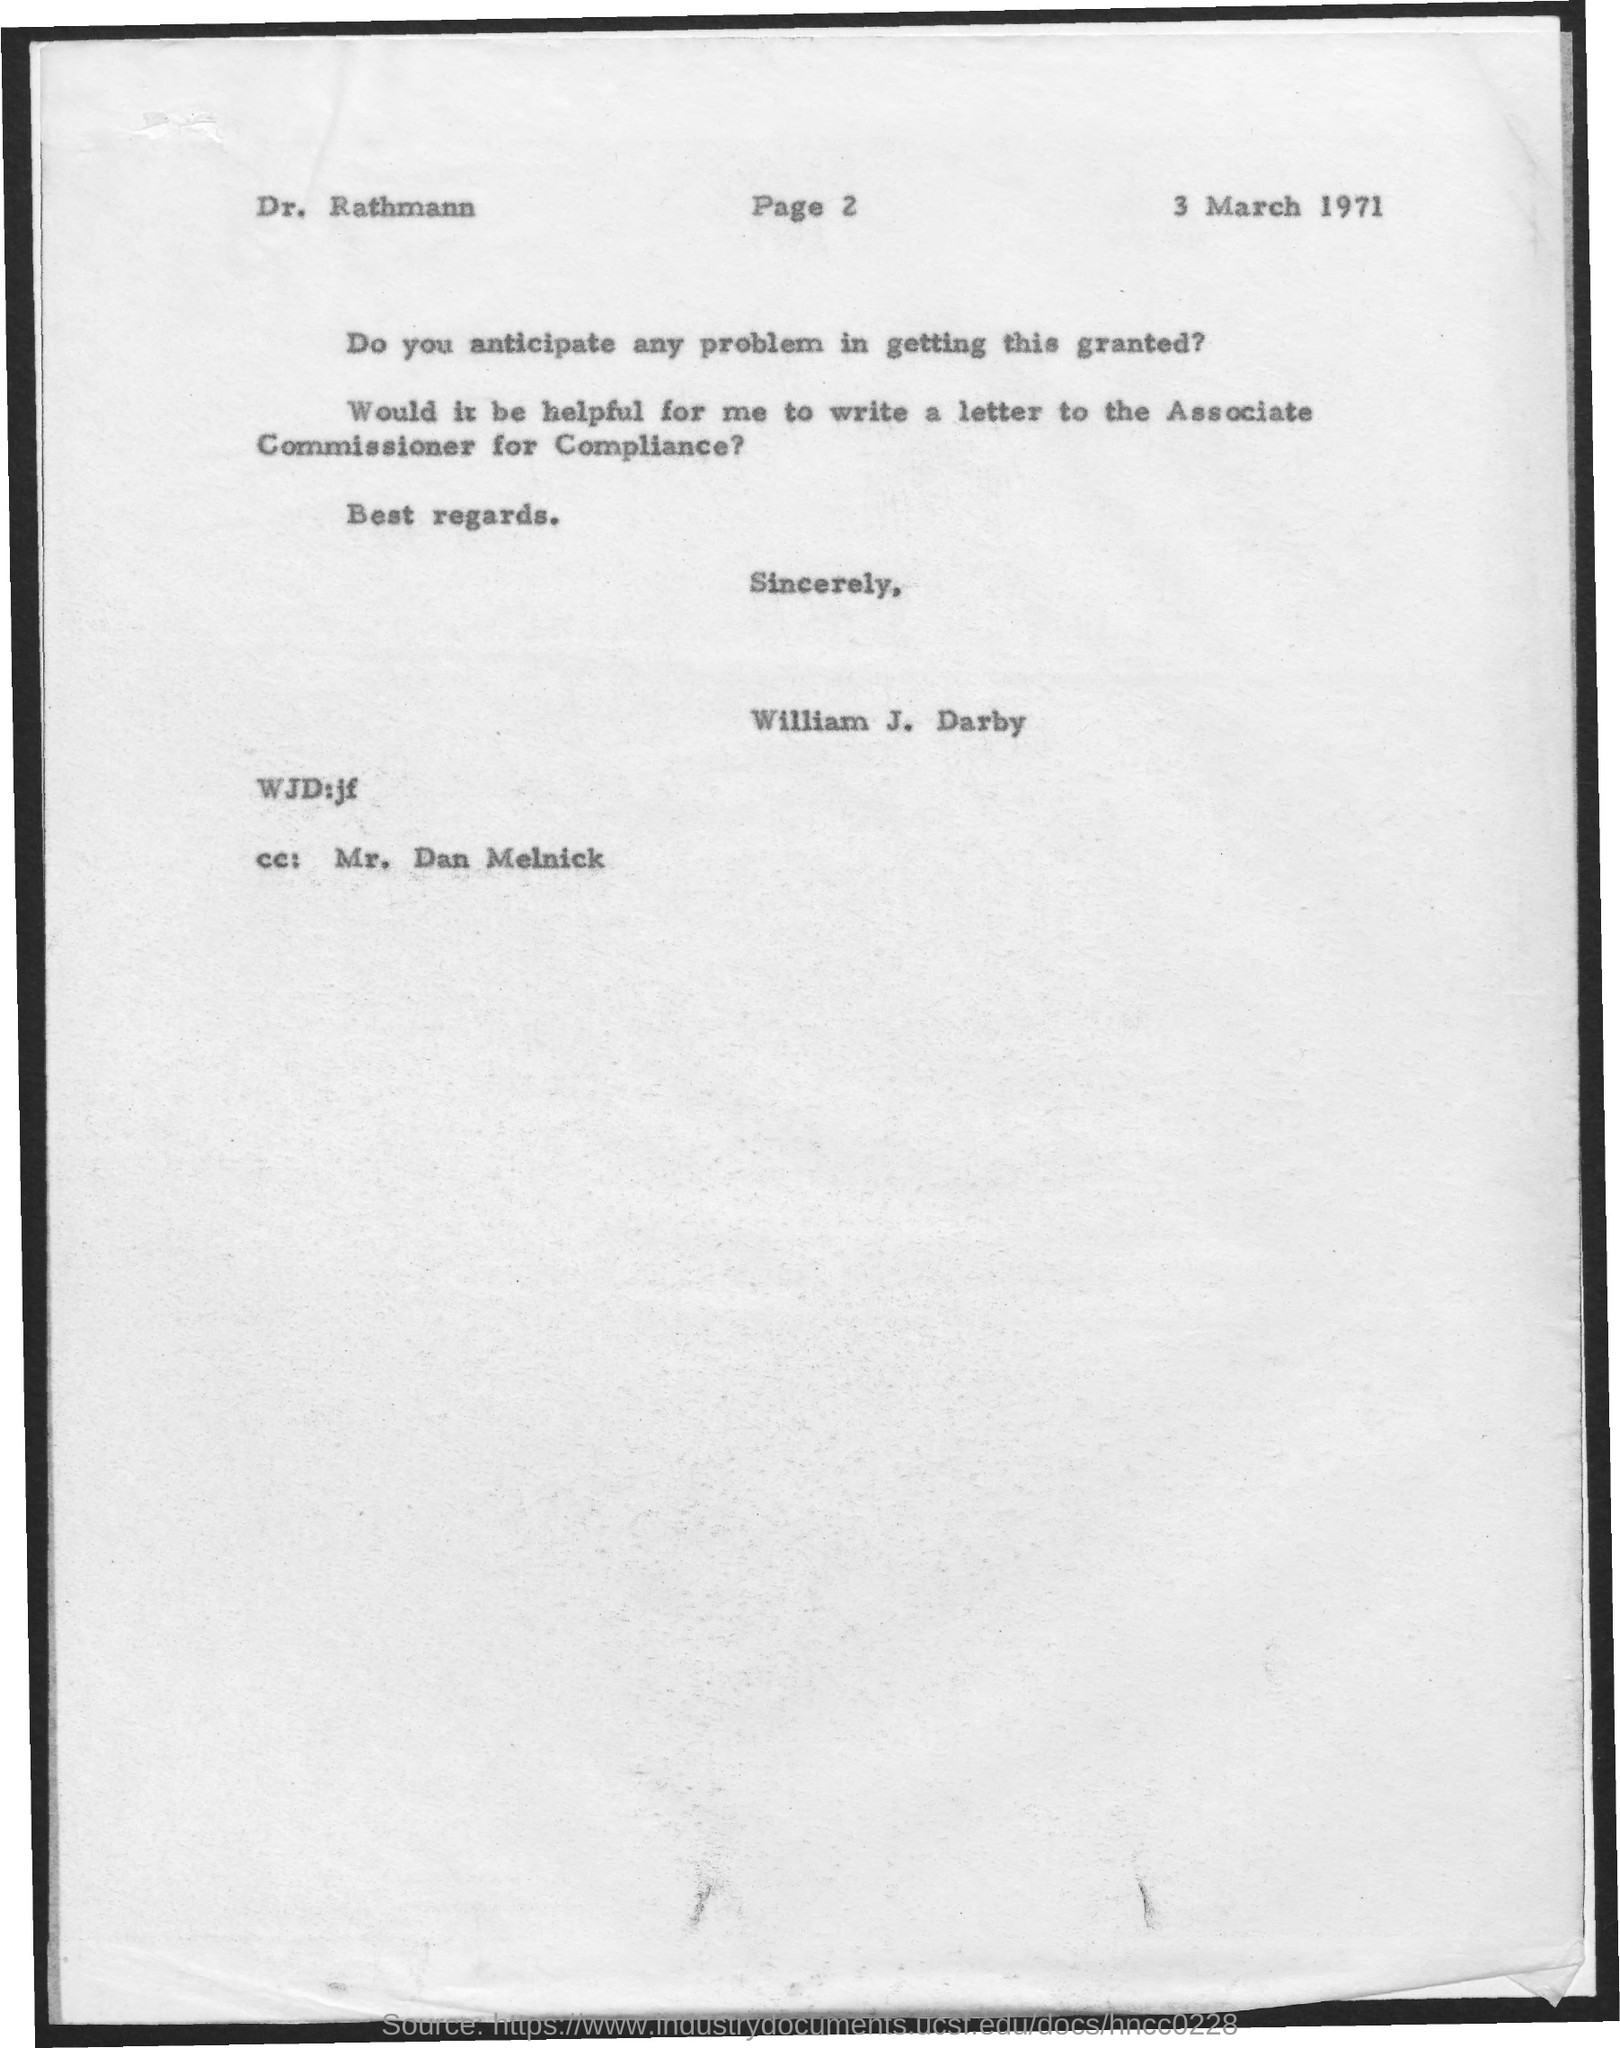Specify some key components in this picture. The letter is addressed to DR. RATHMANN. The date on the document is 3 March 1971. Who is the CC? It is Mr. Dan Melnick. The letter is from William J. Darby. 